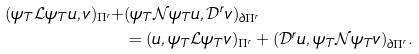<formula> <loc_0><loc_0><loc_500><loc_500>( \psi _ { T } \mathcal { L } \psi _ { T } u , v ) _ { \Pi ^ { r } } + & ( \psi _ { T } \mathcal { N } \psi _ { T } u , \mathcal { D } ^ { r } v ) _ { \partial \Pi ^ { r } } \\ & = ( u , \psi _ { T } \mathcal { L } \psi _ { T } v ) _ { \Pi ^ { r } } + ( \mathcal { D } ^ { r } u , \psi _ { T } \mathcal { N } \psi _ { T } v ) _ { \partial \Pi ^ { r } } .</formula> 